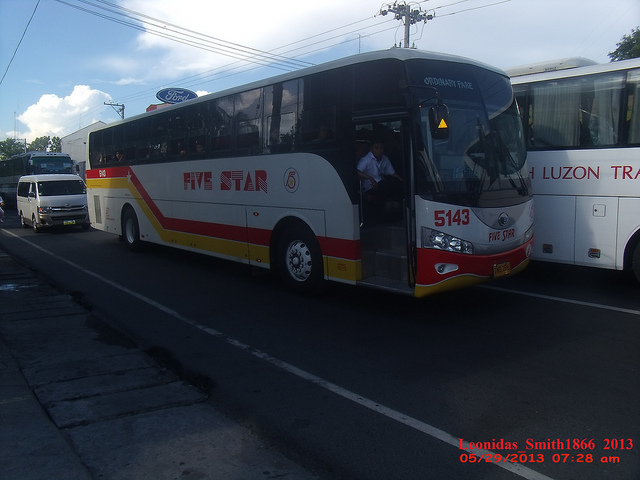Extract all visible text content from this image. 05 FIVE STAR 5143 LUZON am 28 07 2013 29 2013 1866 Smith Leonidas FORD TR 